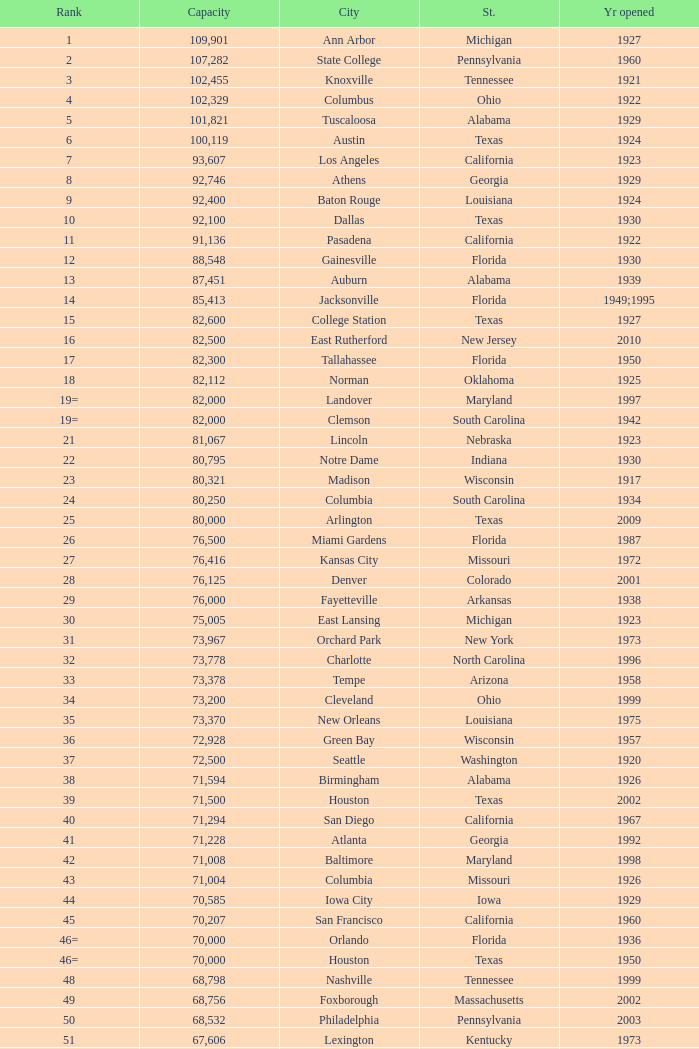What is the rank for the year opened in 1959 in Pennsylvania? 134=. 